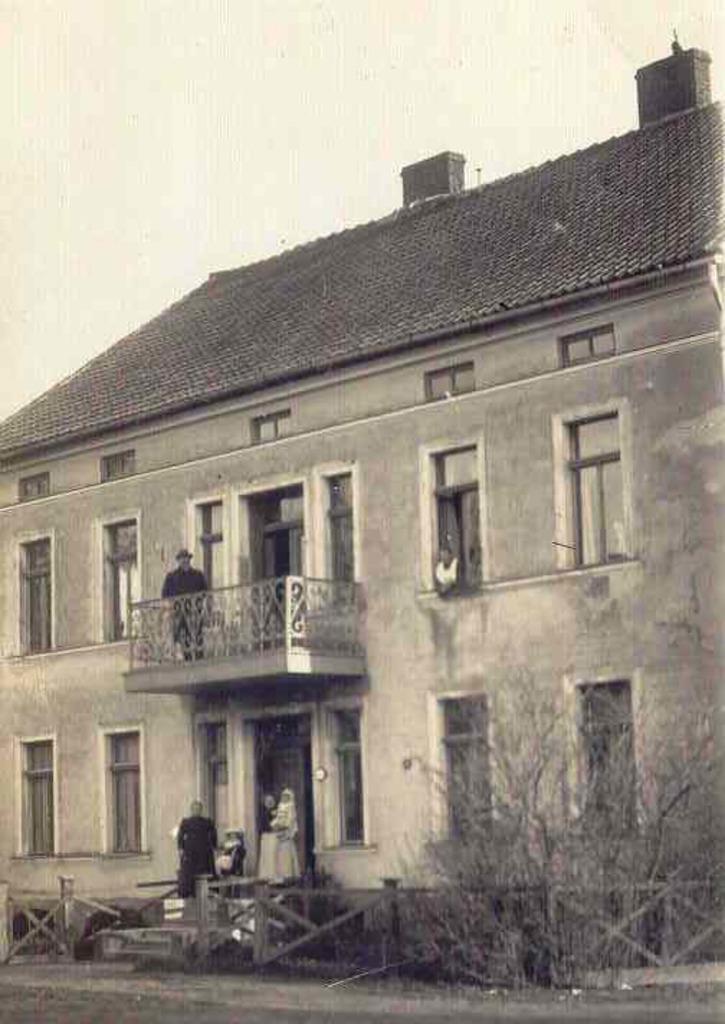Please provide a concise description of this image. In this picture I can see a building and few people standing and I can see a human peeking out from the window and a cloudy sky and few trees. 